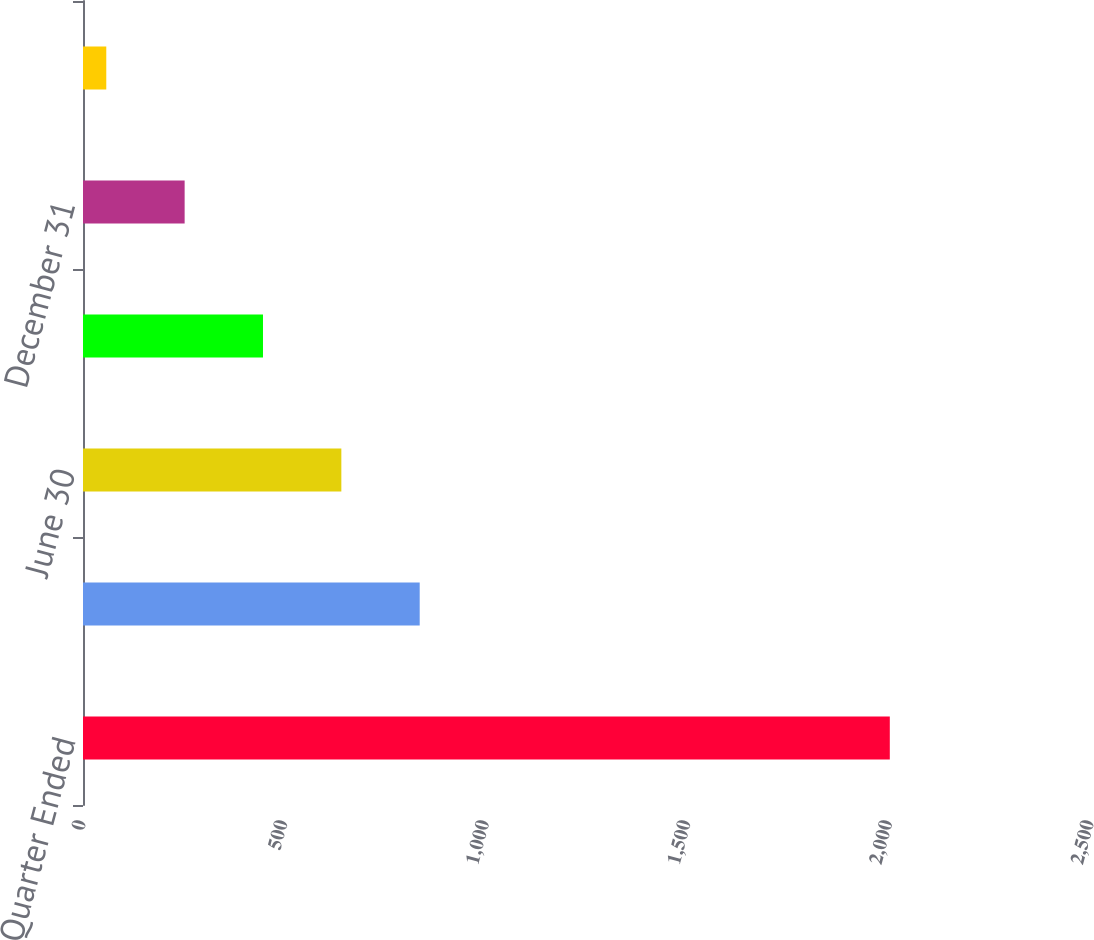<chart> <loc_0><loc_0><loc_500><loc_500><bar_chart><fcel>Quarter Ended<fcel>March 31<fcel>June 30<fcel>September 30<fcel>December 31<fcel>Closing Price<nl><fcel>2001<fcel>835.07<fcel>640.74<fcel>446.41<fcel>252.08<fcel>57.75<nl></chart> 